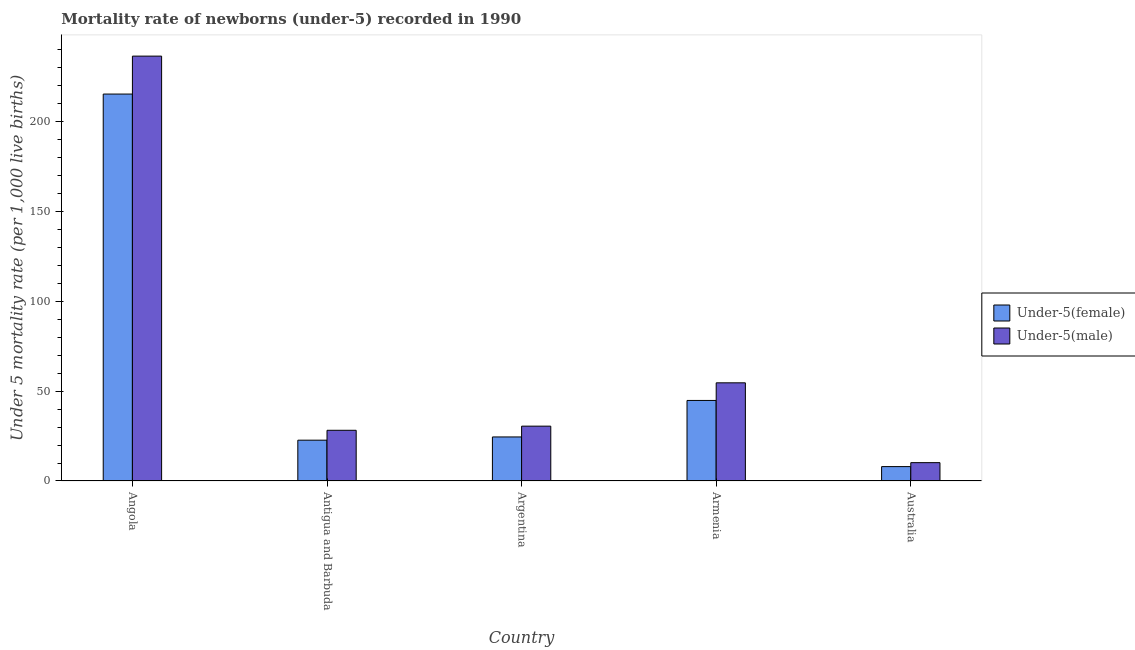How many different coloured bars are there?
Offer a terse response. 2. How many groups of bars are there?
Your answer should be compact. 5. Are the number of bars per tick equal to the number of legend labels?
Your answer should be compact. Yes. How many bars are there on the 5th tick from the left?
Your answer should be compact. 2. How many bars are there on the 5th tick from the right?
Make the answer very short. 2. What is the label of the 5th group of bars from the left?
Keep it short and to the point. Australia. What is the under-5 female mortality rate in Antigua and Barbuda?
Your response must be concise. 22.7. Across all countries, what is the maximum under-5 female mortality rate?
Your answer should be very brief. 215.2. Across all countries, what is the minimum under-5 female mortality rate?
Provide a short and direct response. 8. In which country was the under-5 female mortality rate maximum?
Your answer should be very brief. Angola. In which country was the under-5 female mortality rate minimum?
Keep it short and to the point. Australia. What is the total under-5 male mortality rate in the graph?
Offer a terse response. 359.8. What is the difference between the under-5 male mortality rate in Armenia and that in Australia?
Your answer should be very brief. 44.4. What is the difference between the under-5 male mortality rate in Argentina and the under-5 female mortality rate in Armenia?
Provide a succinct answer. -14.3. What is the average under-5 male mortality rate per country?
Give a very brief answer. 71.96. In how many countries, is the under-5 female mortality rate greater than 150 ?
Offer a very short reply. 1. What is the ratio of the under-5 male mortality rate in Angola to that in Argentina?
Your answer should be very brief. 7.75. Is the under-5 female mortality rate in Angola less than that in Australia?
Give a very brief answer. No. What is the difference between the highest and the second highest under-5 male mortality rate?
Provide a short and direct response. 181.7. What is the difference between the highest and the lowest under-5 male mortality rate?
Offer a terse response. 226.1. What does the 1st bar from the left in Angola represents?
Your response must be concise. Under-5(female). What does the 1st bar from the right in Armenia represents?
Provide a short and direct response. Under-5(male). How many countries are there in the graph?
Make the answer very short. 5. What is the difference between two consecutive major ticks on the Y-axis?
Provide a short and direct response. 50. Does the graph contain any zero values?
Your response must be concise. No. Where does the legend appear in the graph?
Ensure brevity in your answer.  Center right. How many legend labels are there?
Provide a succinct answer. 2. How are the legend labels stacked?
Your answer should be compact. Vertical. What is the title of the graph?
Make the answer very short. Mortality rate of newborns (under-5) recorded in 1990. What is the label or title of the X-axis?
Offer a terse response. Country. What is the label or title of the Y-axis?
Offer a very short reply. Under 5 mortality rate (per 1,0 live births). What is the Under 5 mortality rate (per 1,000 live births) in Under-5(female) in Angola?
Offer a very short reply. 215.2. What is the Under 5 mortality rate (per 1,000 live births) of Under-5(male) in Angola?
Ensure brevity in your answer.  236.3. What is the Under 5 mortality rate (per 1,000 live births) in Under-5(female) in Antigua and Barbuda?
Give a very brief answer. 22.7. What is the Under 5 mortality rate (per 1,000 live births) in Under-5(male) in Antigua and Barbuda?
Provide a short and direct response. 28.2. What is the Under 5 mortality rate (per 1,000 live births) of Under-5(female) in Argentina?
Provide a succinct answer. 24.5. What is the Under 5 mortality rate (per 1,000 live births) in Under-5(male) in Argentina?
Your response must be concise. 30.5. What is the Under 5 mortality rate (per 1,000 live births) in Under-5(female) in Armenia?
Ensure brevity in your answer.  44.8. What is the Under 5 mortality rate (per 1,000 live births) in Under-5(male) in Armenia?
Offer a very short reply. 54.6. What is the Under 5 mortality rate (per 1,000 live births) in Under-5(male) in Australia?
Provide a succinct answer. 10.2. Across all countries, what is the maximum Under 5 mortality rate (per 1,000 live births) of Under-5(female)?
Your answer should be compact. 215.2. Across all countries, what is the maximum Under 5 mortality rate (per 1,000 live births) in Under-5(male)?
Provide a short and direct response. 236.3. Across all countries, what is the minimum Under 5 mortality rate (per 1,000 live births) of Under-5(female)?
Your answer should be compact. 8. Across all countries, what is the minimum Under 5 mortality rate (per 1,000 live births) in Under-5(male)?
Ensure brevity in your answer.  10.2. What is the total Under 5 mortality rate (per 1,000 live births) of Under-5(female) in the graph?
Keep it short and to the point. 315.2. What is the total Under 5 mortality rate (per 1,000 live births) in Under-5(male) in the graph?
Keep it short and to the point. 359.8. What is the difference between the Under 5 mortality rate (per 1,000 live births) in Under-5(female) in Angola and that in Antigua and Barbuda?
Your response must be concise. 192.5. What is the difference between the Under 5 mortality rate (per 1,000 live births) of Under-5(male) in Angola and that in Antigua and Barbuda?
Offer a very short reply. 208.1. What is the difference between the Under 5 mortality rate (per 1,000 live births) of Under-5(female) in Angola and that in Argentina?
Your answer should be very brief. 190.7. What is the difference between the Under 5 mortality rate (per 1,000 live births) of Under-5(male) in Angola and that in Argentina?
Ensure brevity in your answer.  205.8. What is the difference between the Under 5 mortality rate (per 1,000 live births) of Under-5(female) in Angola and that in Armenia?
Offer a very short reply. 170.4. What is the difference between the Under 5 mortality rate (per 1,000 live births) of Under-5(male) in Angola and that in Armenia?
Keep it short and to the point. 181.7. What is the difference between the Under 5 mortality rate (per 1,000 live births) of Under-5(female) in Angola and that in Australia?
Offer a very short reply. 207.2. What is the difference between the Under 5 mortality rate (per 1,000 live births) in Under-5(male) in Angola and that in Australia?
Make the answer very short. 226.1. What is the difference between the Under 5 mortality rate (per 1,000 live births) of Under-5(male) in Antigua and Barbuda and that in Argentina?
Ensure brevity in your answer.  -2.3. What is the difference between the Under 5 mortality rate (per 1,000 live births) in Under-5(female) in Antigua and Barbuda and that in Armenia?
Provide a succinct answer. -22.1. What is the difference between the Under 5 mortality rate (per 1,000 live births) in Under-5(male) in Antigua and Barbuda and that in Armenia?
Your answer should be compact. -26.4. What is the difference between the Under 5 mortality rate (per 1,000 live births) of Under-5(female) in Argentina and that in Armenia?
Your answer should be compact. -20.3. What is the difference between the Under 5 mortality rate (per 1,000 live births) of Under-5(male) in Argentina and that in Armenia?
Provide a succinct answer. -24.1. What is the difference between the Under 5 mortality rate (per 1,000 live births) of Under-5(female) in Argentina and that in Australia?
Keep it short and to the point. 16.5. What is the difference between the Under 5 mortality rate (per 1,000 live births) in Under-5(male) in Argentina and that in Australia?
Your answer should be compact. 20.3. What is the difference between the Under 5 mortality rate (per 1,000 live births) of Under-5(female) in Armenia and that in Australia?
Offer a terse response. 36.8. What is the difference between the Under 5 mortality rate (per 1,000 live births) of Under-5(male) in Armenia and that in Australia?
Your answer should be compact. 44.4. What is the difference between the Under 5 mortality rate (per 1,000 live births) of Under-5(female) in Angola and the Under 5 mortality rate (per 1,000 live births) of Under-5(male) in Antigua and Barbuda?
Your response must be concise. 187. What is the difference between the Under 5 mortality rate (per 1,000 live births) of Under-5(female) in Angola and the Under 5 mortality rate (per 1,000 live births) of Under-5(male) in Argentina?
Ensure brevity in your answer.  184.7. What is the difference between the Under 5 mortality rate (per 1,000 live births) in Under-5(female) in Angola and the Under 5 mortality rate (per 1,000 live births) in Under-5(male) in Armenia?
Offer a very short reply. 160.6. What is the difference between the Under 5 mortality rate (per 1,000 live births) of Under-5(female) in Angola and the Under 5 mortality rate (per 1,000 live births) of Under-5(male) in Australia?
Provide a short and direct response. 205. What is the difference between the Under 5 mortality rate (per 1,000 live births) in Under-5(female) in Antigua and Barbuda and the Under 5 mortality rate (per 1,000 live births) in Under-5(male) in Argentina?
Your answer should be very brief. -7.8. What is the difference between the Under 5 mortality rate (per 1,000 live births) in Under-5(female) in Antigua and Barbuda and the Under 5 mortality rate (per 1,000 live births) in Under-5(male) in Armenia?
Make the answer very short. -31.9. What is the difference between the Under 5 mortality rate (per 1,000 live births) of Under-5(female) in Argentina and the Under 5 mortality rate (per 1,000 live births) of Under-5(male) in Armenia?
Provide a short and direct response. -30.1. What is the difference between the Under 5 mortality rate (per 1,000 live births) of Under-5(female) in Argentina and the Under 5 mortality rate (per 1,000 live births) of Under-5(male) in Australia?
Offer a terse response. 14.3. What is the difference between the Under 5 mortality rate (per 1,000 live births) of Under-5(female) in Armenia and the Under 5 mortality rate (per 1,000 live births) of Under-5(male) in Australia?
Your response must be concise. 34.6. What is the average Under 5 mortality rate (per 1,000 live births) in Under-5(female) per country?
Your response must be concise. 63.04. What is the average Under 5 mortality rate (per 1,000 live births) in Under-5(male) per country?
Offer a terse response. 71.96. What is the difference between the Under 5 mortality rate (per 1,000 live births) in Under-5(female) and Under 5 mortality rate (per 1,000 live births) in Under-5(male) in Angola?
Offer a terse response. -21.1. What is the difference between the Under 5 mortality rate (per 1,000 live births) in Under-5(female) and Under 5 mortality rate (per 1,000 live births) in Under-5(male) in Antigua and Barbuda?
Your answer should be very brief. -5.5. What is the difference between the Under 5 mortality rate (per 1,000 live births) of Under-5(female) and Under 5 mortality rate (per 1,000 live births) of Under-5(male) in Argentina?
Offer a very short reply. -6. What is the ratio of the Under 5 mortality rate (per 1,000 live births) of Under-5(female) in Angola to that in Antigua and Barbuda?
Offer a terse response. 9.48. What is the ratio of the Under 5 mortality rate (per 1,000 live births) in Under-5(male) in Angola to that in Antigua and Barbuda?
Make the answer very short. 8.38. What is the ratio of the Under 5 mortality rate (per 1,000 live births) of Under-5(female) in Angola to that in Argentina?
Ensure brevity in your answer.  8.78. What is the ratio of the Under 5 mortality rate (per 1,000 live births) of Under-5(male) in Angola to that in Argentina?
Give a very brief answer. 7.75. What is the ratio of the Under 5 mortality rate (per 1,000 live births) in Under-5(female) in Angola to that in Armenia?
Your response must be concise. 4.8. What is the ratio of the Under 5 mortality rate (per 1,000 live births) of Under-5(male) in Angola to that in Armenia?
Offer a very short reply. 4.33. What is the ratio of the Under 5 mortality rate (per 1,000 live births) of Under-5(female) in Angola to that in Australia?
Your answer should be compact. 26.9. What is the ratio of the Under 5 mortality rate (per 1,000 live births) of Under-5(male) in Angola to that in Australia?
Ensure brevity in your answer.  23.17. What is the ratio of the Under 5 mortality rate (per 1,000 live births) in Under-5(female) in Antigua and Barbuda to that in Argentina?
Provide a short and direct response. 0.93. What is the ratio of the Under 5 mortality rate (per 1,000 live births) of Under-5(male) in Antigua and Barbuda to that in Argentina?
Provide a succinct answer. 0.92. What is the ratio of the Under 5 mortality rate (per 1,000 live births) of Under-5(female) in Antigua and Barbuda to that in Armenia?
Offer a terse response. 0.51. What is the ratio of the Under 5 mortality rate (per 1,000 live births) of Under-5(male) in Antigua and Barbuda to that in Armenia?
Offer a terse response. 0.52. What is the ratio of the Under 5 mortality rate (per 1,000 live births) of Under-5(female) in Antigua and Barbuda to that in Australia?
Make the answer very short. 2.84. What is the ratio of the Under 5 mortality rate (per 1,000 live births) of Under-5(male) in Antigua and Barbuda to that in Australia?
Your answer should be very brief. 2.76. What is the ratio of the Under 5 mortality rate (per 1,000 live births) of Under-5(female) in Argentina to that in Armenia?
Give a very brief answer. 0.55. What is the ratio of the Under 5 mortality rate (per 1,000 live births) of Under-5(male) in Argentina to that in Armenia?
Ensure brevity in your answer.  0.56. What is the ratio of the Under 5 mortality rate (per 1,000 live births) of Under-5(female) in Argentina to that in Australia?
Your response must be concise. 3.06. What is the ratio of the Under 5 mortality rate (per 1,000 live births) of Under-5(male) in Argentina to that in Australia?
Provide a short and direct response. 2.99. What is the ratio of the Under 5 mortality rate (per 1,000 live births) of Under-5(female) in Armenia to that in Australia?
Ensure brevity in your answer.  5.6. What is the ratio of the Under 5 mortality rate (per 1,000 live births) in Under-5(male) in Armenia to that in Australia?
Your response must be concise. 5.35. What is the difference between the highest and the second highest Under 5 mortality rate (per 1,000 live births) of Under-5(female)?
Provide a succinct answer. 170.4. What is the difference between the highest and the second highest Under 5 mortality rate (per 1,000 live births) of Under-5(male)?
Your answer should be very brief. 181.7. What is the difference between the highest and the lowest Under 5 mortality rate (per 1,000 live births) of Under-5(female)?
Your answer should be very brief. 207.2. What is the difference between the highest and the lowest Under 5 mortality rate (per 1,000 live births) in Under-5(male)?
Provide a short and direct response. 226.1. 